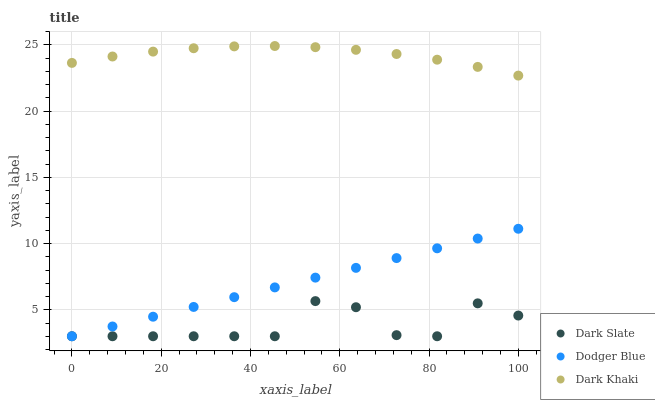Does Dark Slate have the minimum area under the curve?
Answer yes or no. Yes. Does Dark Khaki have the maximum area under the curve?
Answer yes or no. Yes. Does Dodger Blue have the minimum area under the curve?
Answer yes or no. No. Does Dodger Blue have the maximum area under the curve?
Answer yes or no. No. Is Dodger Blue the smoothest?
Answer yes or no. Yes. Is Dark Slate the roughest?
Answer yes or no. Yes. Is Dark Slate the smoothest?
Answer yes or no. No. Is Dodger Blue the roughest?
Answer yes or no. No. Does Dark Slate have the lowest value?
Answer yes or no. Yes. Does Dark Khaki have the highest value?
Answer yes or no. Yes. Does Dodger Blue have the highest value?
Answer yes or no. No. Is Dodger Blue less than Dark Khaki?
Answer yes or no. Yes. Is Dark Khaki greater than Dodger Blue?
Answer yes or no. Yes. Does Dodger Blue intersect Dark Slate?
Answer yes or no. Yes. Is Dodger Blue less than Dark Slate?
Answer yes or no. No. Is Dodger Blue greater than Dark Slate?
Answer yes or no. No. Does Dodger Blue intersect Dark Khaki?
Answer yes or no. No. 